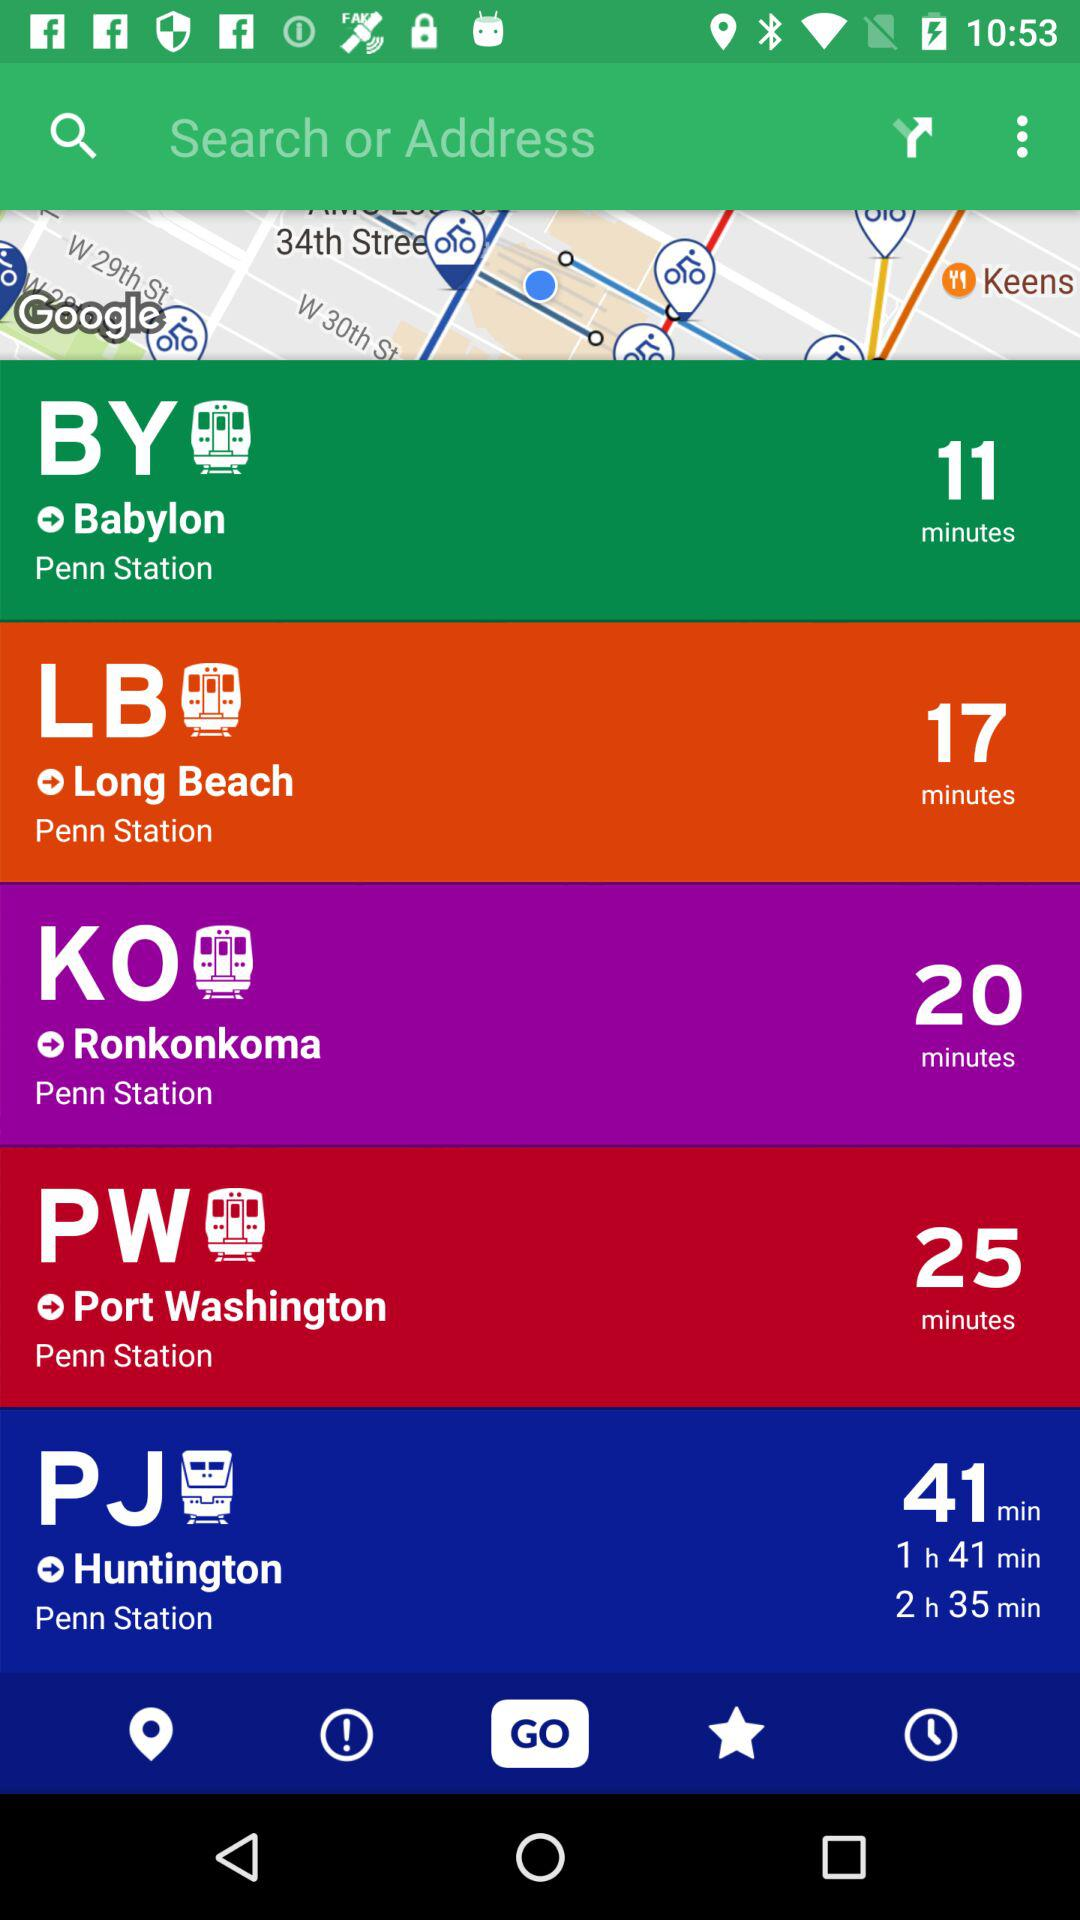What is the name of the station? The names of the stations are "Babylon", "Penn Station", "Long Beach", "Ronkonkoma", "Port Washington" and "Huntington". 